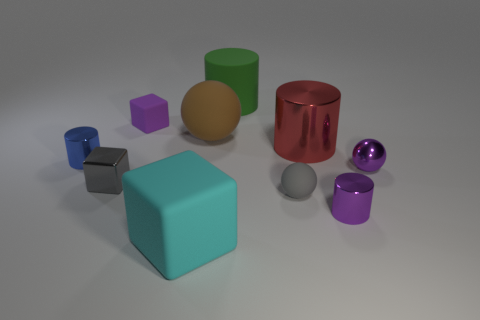How many small shiny objects are the same color as the tiny rubber ball?
Give a very brief answer. 1. Does the tiny cylinder that is on the right side of the small blue thing have the same color as the matte block behind the large cyan rubber block?
Keep it short and to the point. Yes. Are there fewer big rubber things right of the big brown rubber thing than matte cylinders that are right of the purple matte block?
Your answer should be compact. No. Are there any other things that have the same shape as the red object?
Keep it short and to the point. Yes. What is the color of the other tiny thing that is the same shape as the purple matte object?
Give a very brief answer. Gray. There is a large cyan object; does it have the same shape as the rubber object on the right side of the green rubber thing?
Provide a short and direct response. No. How many objects are tiny gray objects that are left of the big cyan matte object or purple objects that are right of the small matte ball?
Your response must be concise. 3. What material is the purple ball?
Your answer should be very brief. Metal. How many other things are there of the same size as the green cylinder?
Give a very brief answer. 3. There is a metallic thing behind the blue object; what size is it?
Provide a short and direct response. Large. 